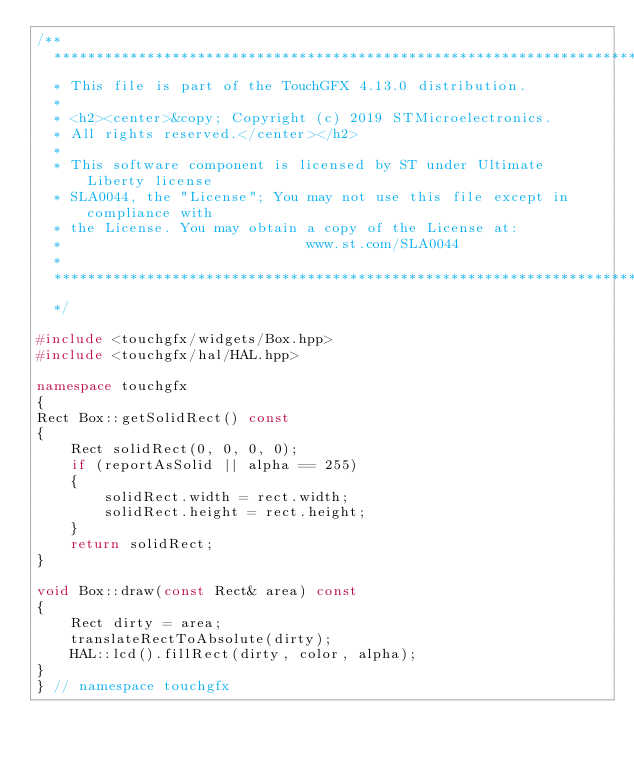Convert code to text. <code><loc_0><loc_0><loc_500><loc_500><_C++_>/**
  ******************************************************************************
  * This file is part of the TouchGFX 4.13.0 distribution.
  *
  * <h2><center>&copy; Copyright (c) 2019 STMicroelectronics.
  * All rights reserved.</center></h2>
  *
  * This software component is licensed by ST under Ultimate Liberty license
  * SLA0044, the "License"; You may not use this file except in compliance with
  * the License. You may obtain a copy of the License at:
  *                             www.st.com/SLA0044
  *
  ******************************************************************************
  */

#include <touchgfx/widgets/Box.hpp>
#include <touchgfx/hal/HAL.hpp>

namespace touchgfx
{
Rect Box::getSolidRect() const
{
    Rect solidRect(0, 0, 0, 0);
    if (reportAsSolid || alpha == 255)
    {
        solidRect.width = rect.width;
        solidRect.height = rect.height;
    }
    return solidRect;
}

void Box::draw(const Rect& area) const
{
    Rect dirty = area;
    translateRectToAbsolute(dirty);
    HAL::lcd().fillRect(dirty, color, alpha);
}
} // namespace touchgfx
</code> 